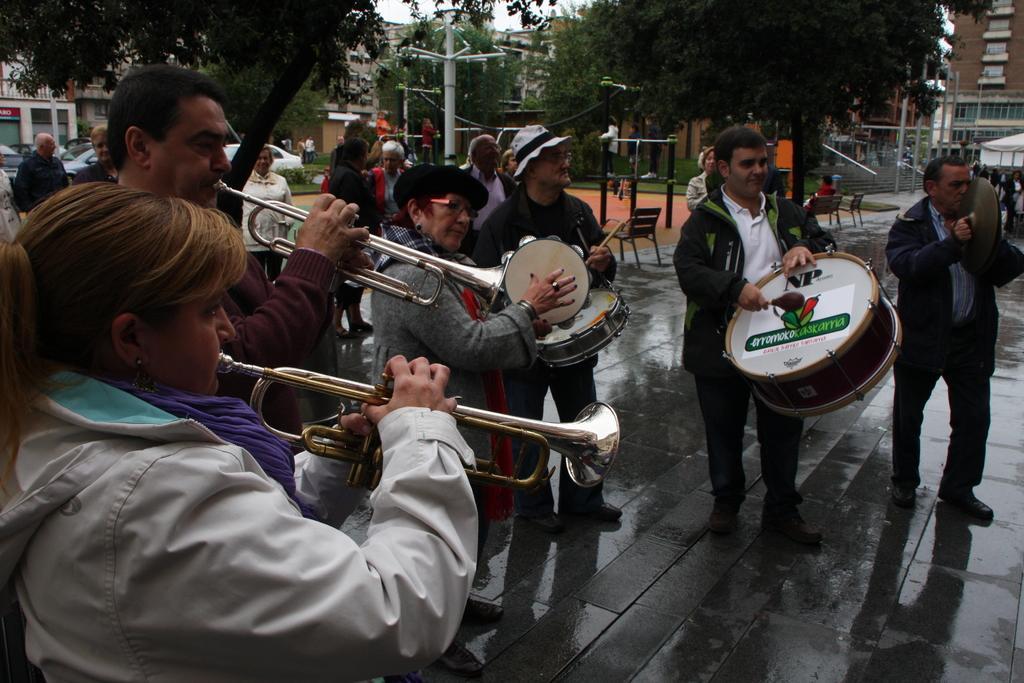Please provide a concise description of this image. In this image few people are playing musical instruments on the road. Few are playing drums, few are playing trumpet. In the background there are vehicles, people. This is looking like a park. There are few benches over here. In the back there are trees, poles, buildings. 